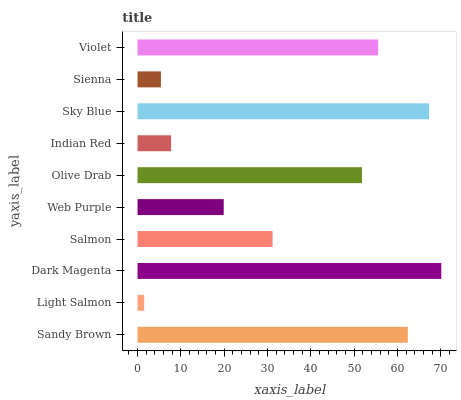Is Light Salmon the minimum?
Answer yes or no. Yes. Is Dark Magenta the maximum?
Answer yes or no. Yes. Is Dark Magenta the minimum?
Answer yes or no. No. Is Light Salmon the maximum?
Answer yes or no. No. Is Dark Magenta greater than Light Salmon?
Answer yes or no. Yes. Is Light Salmon less than Dark Magenta?
Answer yes or no. Yes. Is Light Salmon greater than Dark Magenta?
Answer yes or no. No. Is Dark Magenta less than Light Salmon?
Answer yes or no. No. Is Olive Drab the high median?
Answer yes or no. Yes. Is Salmon the low median?
Answer yes or no. Yes. Is Violet the high median?
Answer yes or no. No. Is Olive Drab the low median?
Answer yes or no. No. 